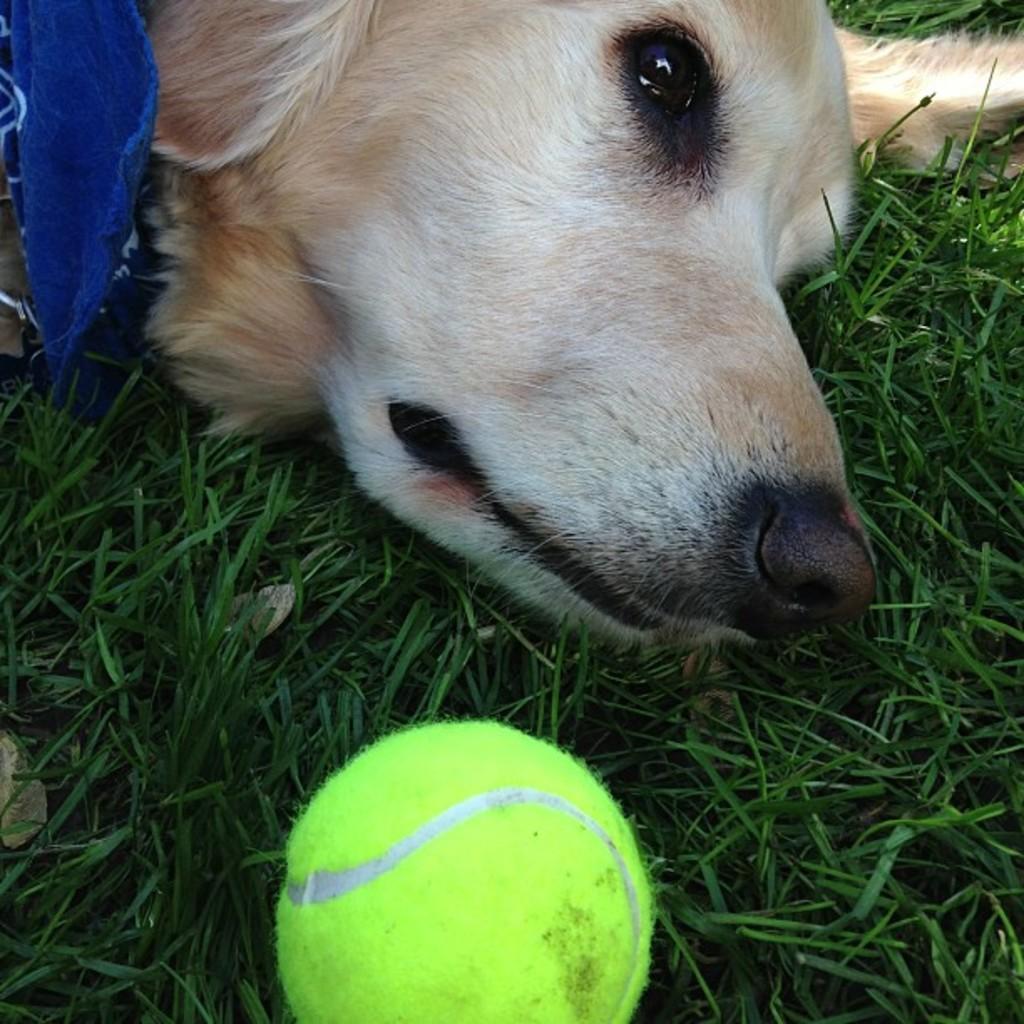Please provide a concise description of this image. In the picture,we can see the head of a dog laying on the grass and in front of the dog there is a ball. 